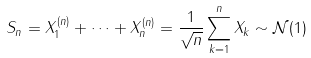Convert formula to latex. <formula><loc_0><loc_0><loc_500><loc_500>S _ { n } = X _ { 1 } ^ { ( n ) } + \dots + X _ { n } ^ { ( n ) } = \frac { 1 } { \sqrt { n } } \sum _ { k = 1 } ^ { n } X _ { k } \sim \mathcal { N } ( 1 )</formula> 